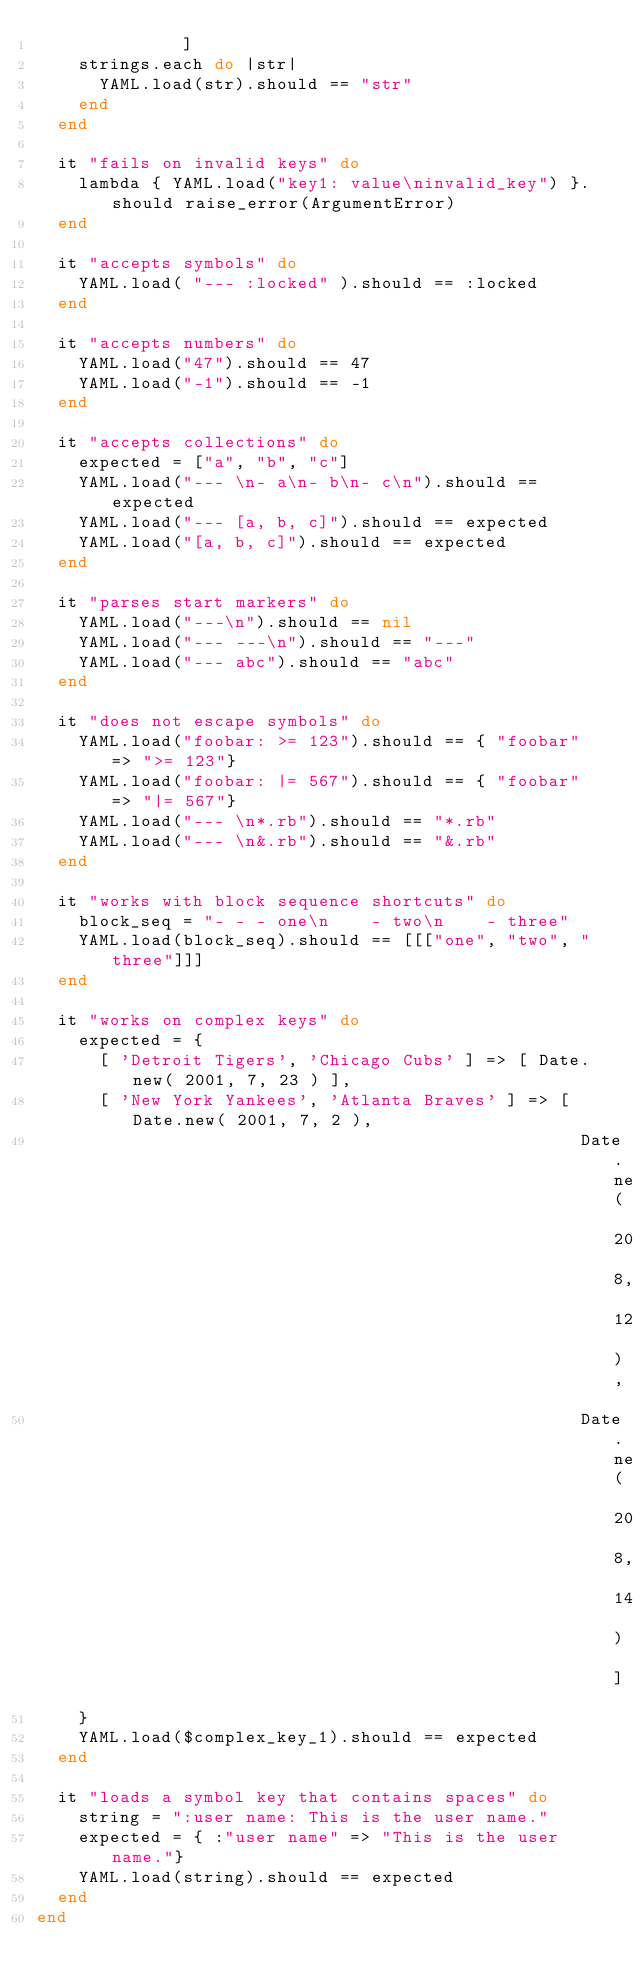<code> <loc_0><loc_0><loc_500><loc_500><_Ruby_>              ]
    strings.each do |str|
      YAML.load(str).should == "str"
    end
  end  

  it "fails on invalid keys" do
    lambda { YAML.load("key1: value\ninvalid_key") }.should raise_error(ArgumentError)
  end

  it "accepts symbols" do
    YAML.load( "--- :locked" ).should == :locked
  end

  it "accepts numbers" do
    YAML.load("47").should == 47
    YAML.load("-1").should == -1
  end

  it "accepts collections" do
    expected = ["a", "b", "c"]
    YAML.load("--- \n- a\n- b\n- c\n").should == expected
    YAML.load("--- [a, b, c]").should == expected
    YAML.load("[a, b, c]").should == expected
  end

  it "parses start markers" do
    YAML.load("---\n").should == nil
    YAML.load("--- ---\n").should == "---"
    YAML.load("--- abc").should == "abc"
  end

  it "does not escape symbols" do
    YAML.load("foobar: >= 123").should == { "foobar" => ">= 123"}
    YAML.load("foobar: |= 567").should == { "foobar" => "|= 567"}
    YAML.load("--- \n*.rb").should == "*.rb"
    YAML.load("--- \n&.rb").should == "&.rb"
  end

  it "works with block sequence shortcuts" do
    block_seq = "- - - one\n    - two\n    - three"
    YAML.load(block_seq).should == [[["one", "two", "three"]]]
  end

  it "works on complex keys" do
    expected = { 
      [ 'Detroit Tigers', 'Chicago Cubs' ] => [ Date.new( 2001, 7, 23 ) ],
      [ 'New York Yankees', 'Atlanta Braves' ] => [ Date.new( 2001, 7, 2 ), 
                                                    Date.new( 2001, 8, 12 ), 
                                                    Date.new( 2001, 8, 14 ) ] 
    }
    YAML.load($complex_key_1).should == expected
  end
  
  it "loads a symbol key that contains spaces" do
    string = ":user name: This is the user name."
    expected = { :"user name" => "This is the user name."}
    YAML.load(string).should == expected
  end
end
</code> 